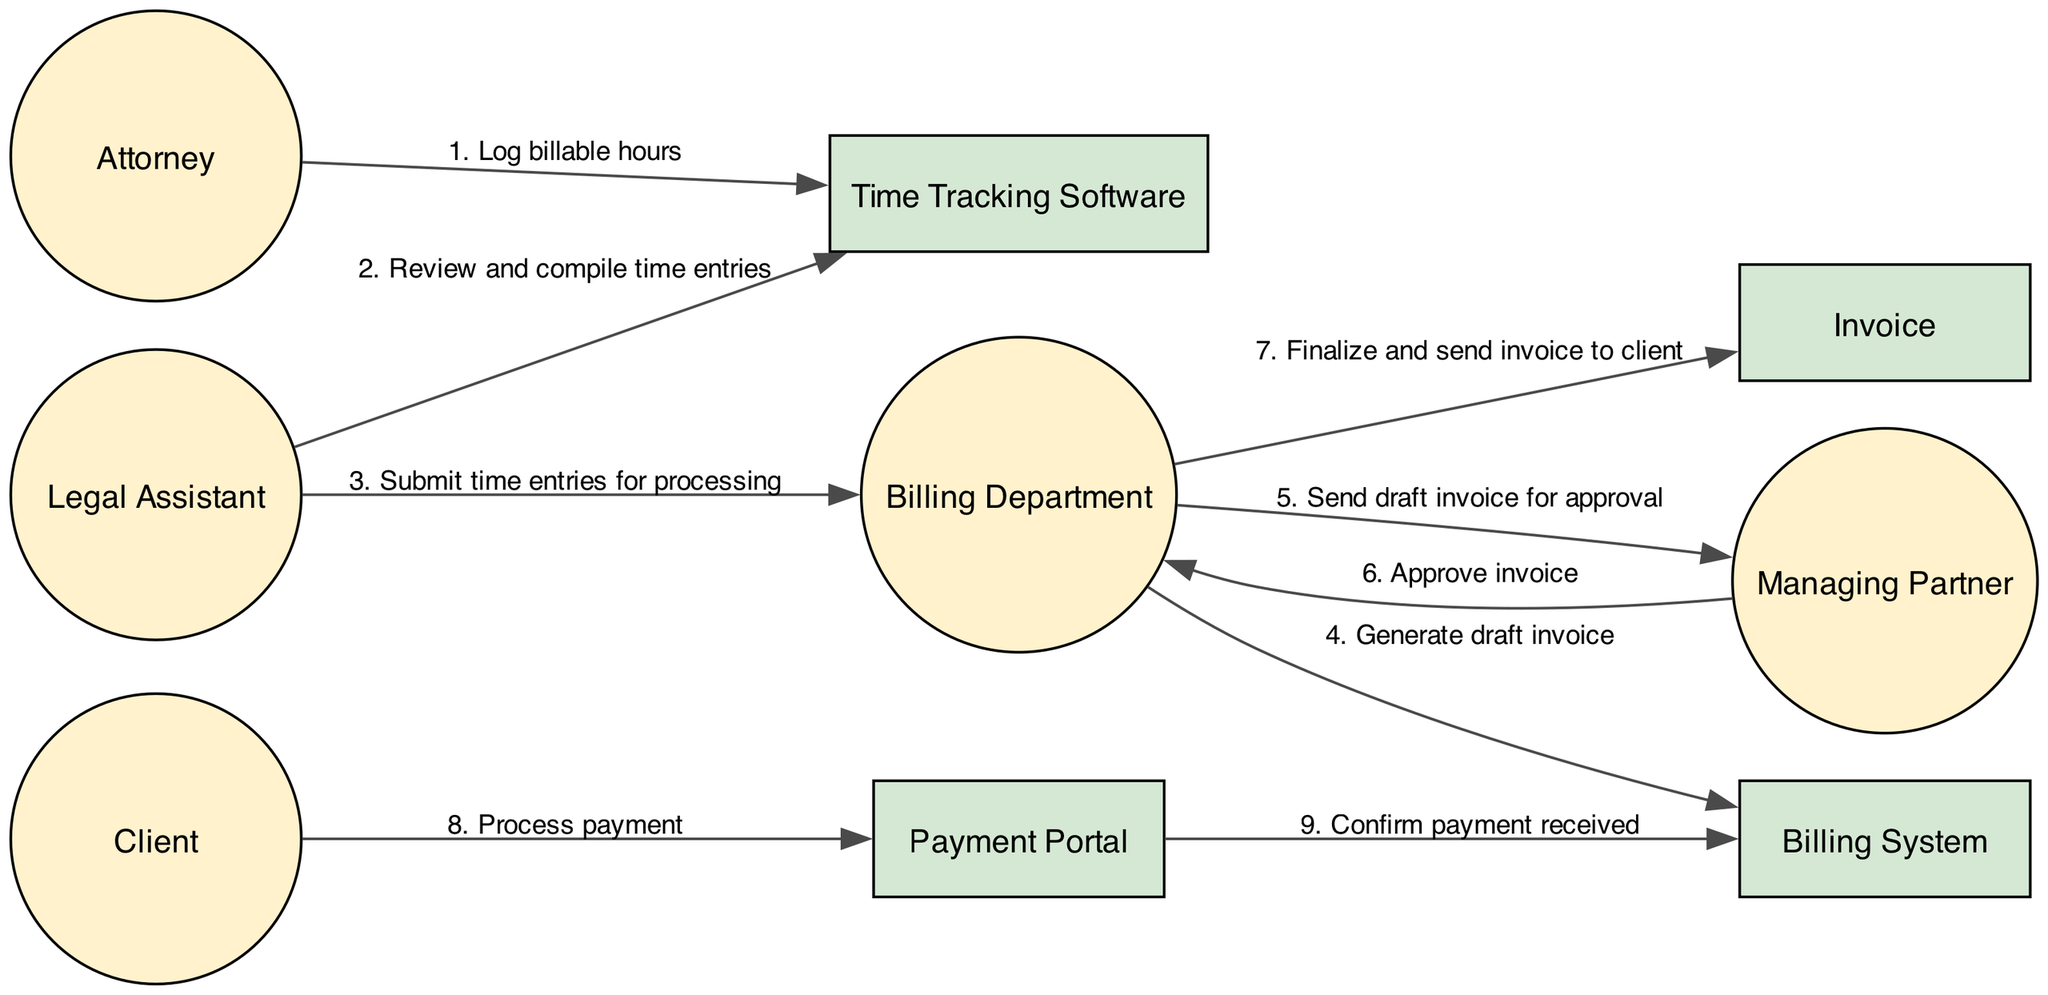What is the first action that the Attorney does? The first action in the sequence diagram is represented by the first edge, which goes from the Attorney to the Time Tracking Software with the message "Log billable hours."
Answer: Log billable hours Who is responsible for reviewing and compiling time entries? The action that involves reviewing and compiling time entries is represented by the edge from the Legal Assistant to the Time Tracking Software, with the message "Review and compile time entries."
Answer: Legal Assistant How many steps are involved in the billing process from timekeeping to client payment? To find the number of steps, we count the actions listed in the diagram. There are a total of 9 actions described in the sequence of the billing process.
Answer: 9 What does the Billing Department send to the Managing Partner for approval? The specific action that indicates this is the edge from the Billing Department to the Managing Partner, labeled "Send draft invoice for approval."
Answer: Draft invoice What is the final outcome of the Billing Department's processing? The final outcome is demonstrated by the action where the Billing Department sends the finalized invoice to the client, as indicated by the edge that leads to the Invoice with the message "Finalize and send invoice to client."
Answer: Send invoice to client Who processes the payment after receiving the invoice? The payment action is initiated by the Client, who communicates with the Payment Portal to complete their payment, represented by the edge from the Client to the Payment Portal with the message "Process payment."
Answer: Client What action confirms that the payment was received? The confirmation of payment received is represented by the edge from the Payment Portal to the Billing System, labeled "Confirm payment received."
Answer: Confirm payment received Which actor sends the final invoice to the client? The edge that indicates the final invoice being sent to the client is from the Billing Department to the Invoice, and is labeled "Finalize and send invoice to client." Therefore, the Billing Department is responsible for sending the final invoice.
Answer: Billing Department 